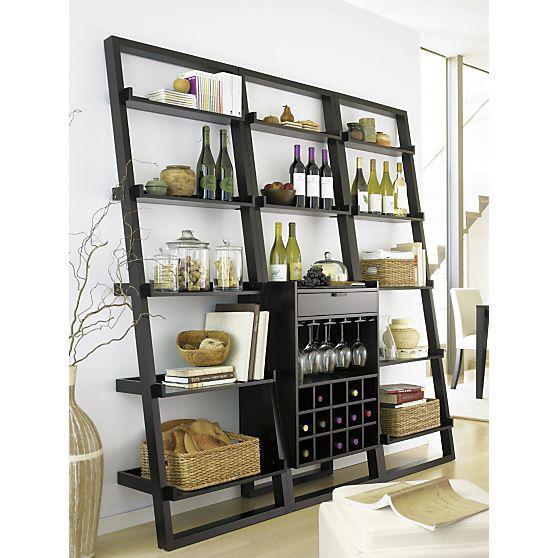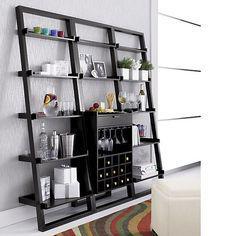The first image is the image on the left, the second image is the image on the right. Given the left and right images, does the statement "In at least one image there is a brown shelving unit with columns of shelves with the middle bottom set of selve using wood to create an x that can hold wine bottles." hold true? Answer yes or no. No. The first image is the image on the left, the second image is the image on the right. Examine the images to the left and right. Is the description "One storage unit has an X-shaped lower compartment for wine bottles, and the other storage unit has individual bins for bottles in a lower compartment." accurate? Answer yes or no. No. 